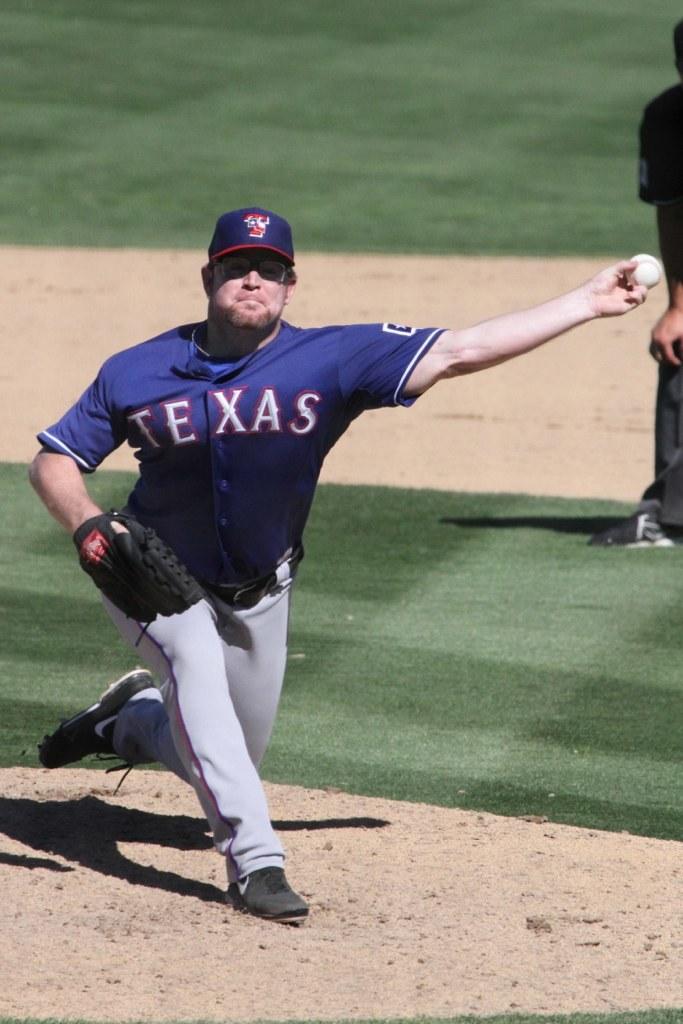What letter is on the player's hat?
Keep it short and to the point. T. 